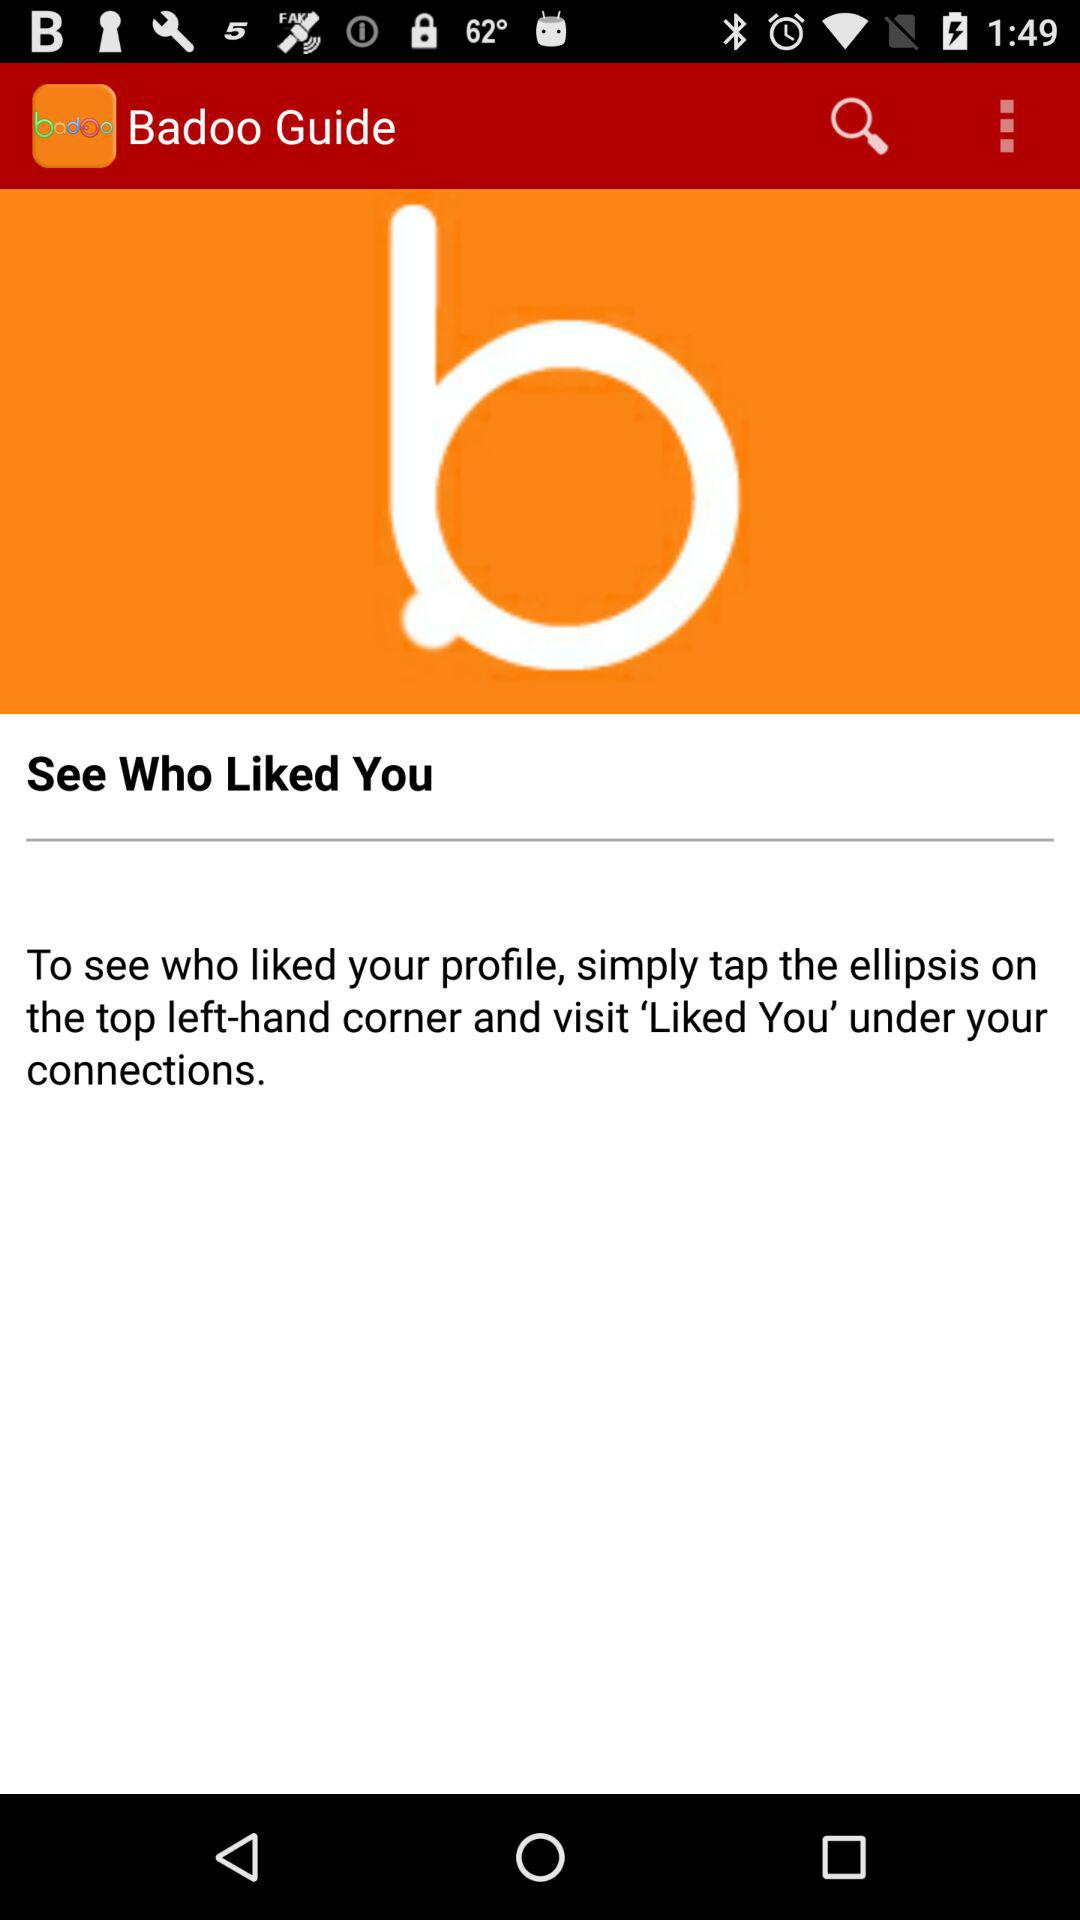What is the application name? The application name is "Badoo Guide". 